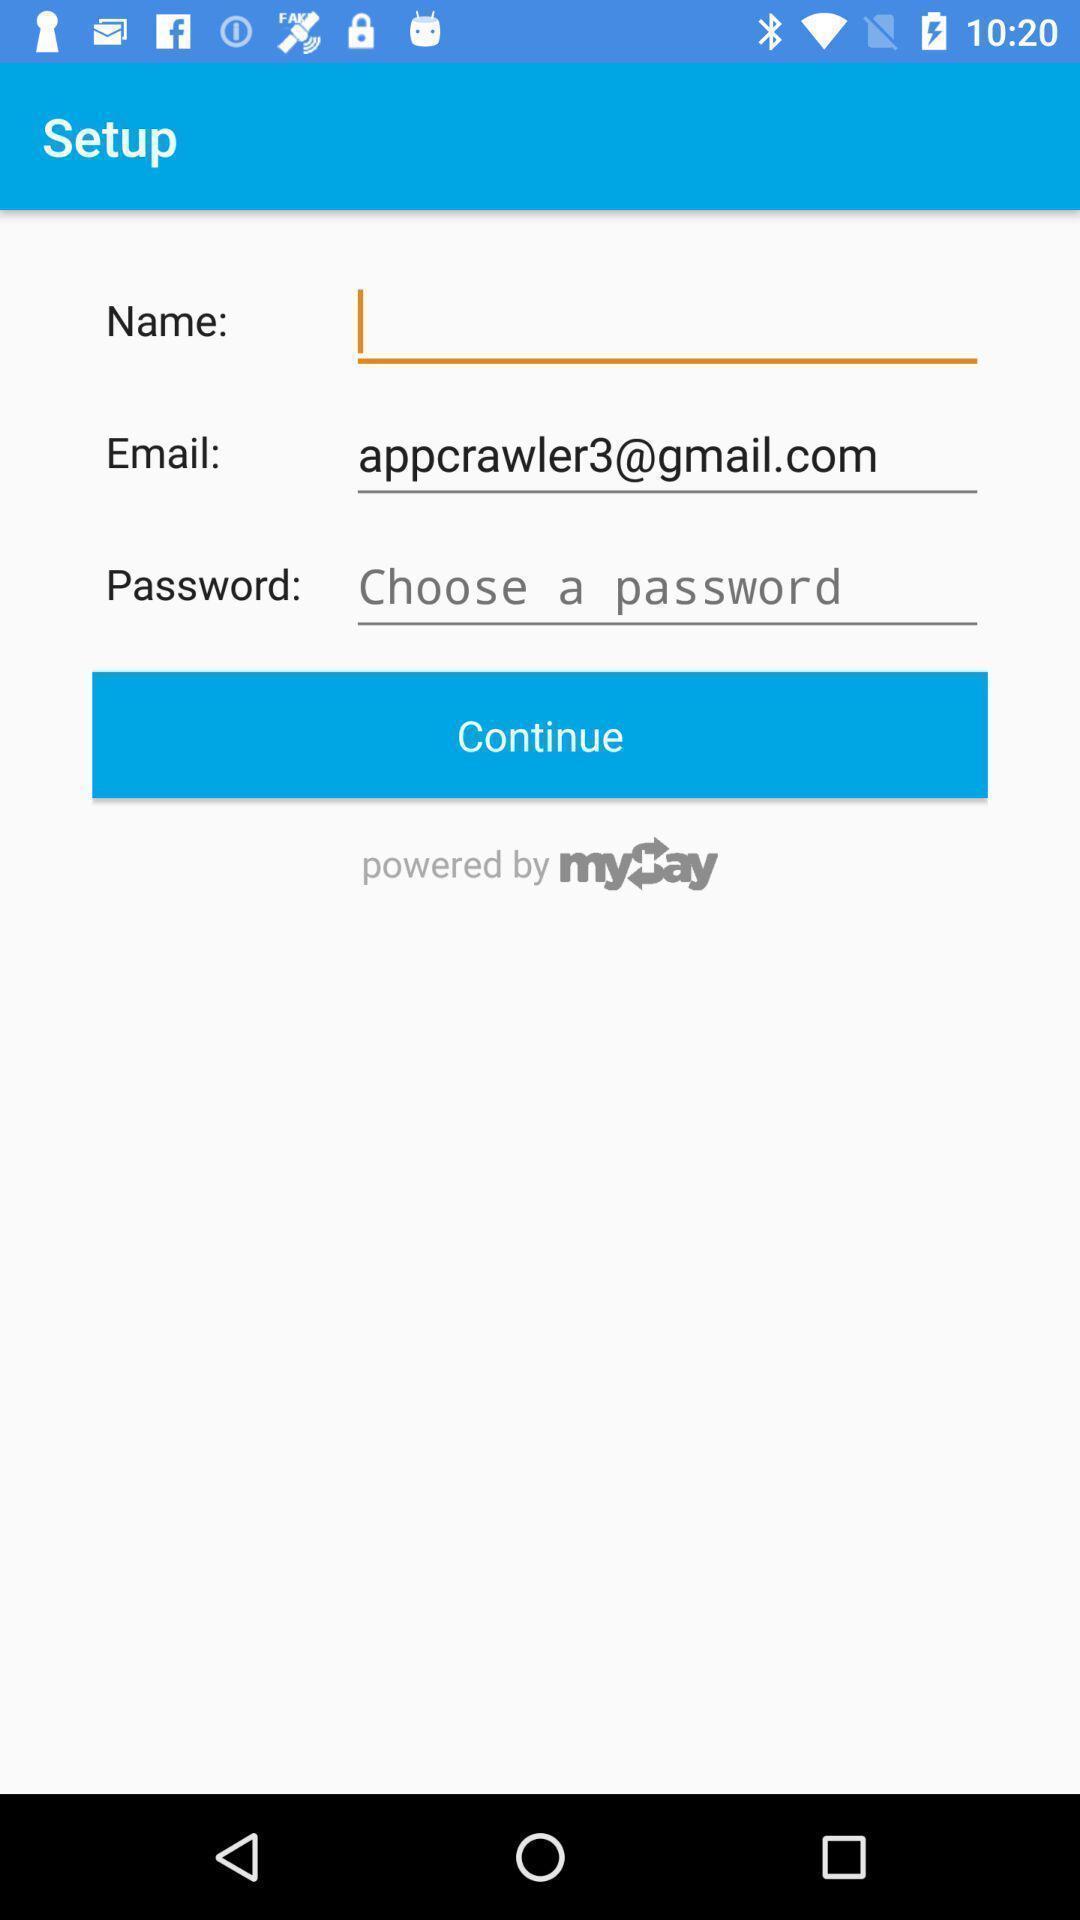Give me a summary of this screen capture. Screen showing set up page. 